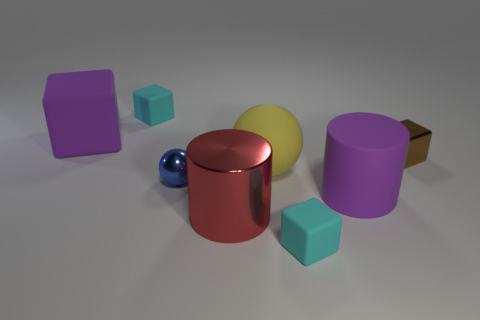How does the use of color affect the composition of the image? The use of color in this image is quite harmonious, with each object featuring a distinct hue that contrasts nicely with the others. This creates a visually engaging arrangement that draws the eye across the scene. The colors are not overly vibrant, which gives the composition a soft and balanced feel, emphasizing the objects' shapes and material textures. 